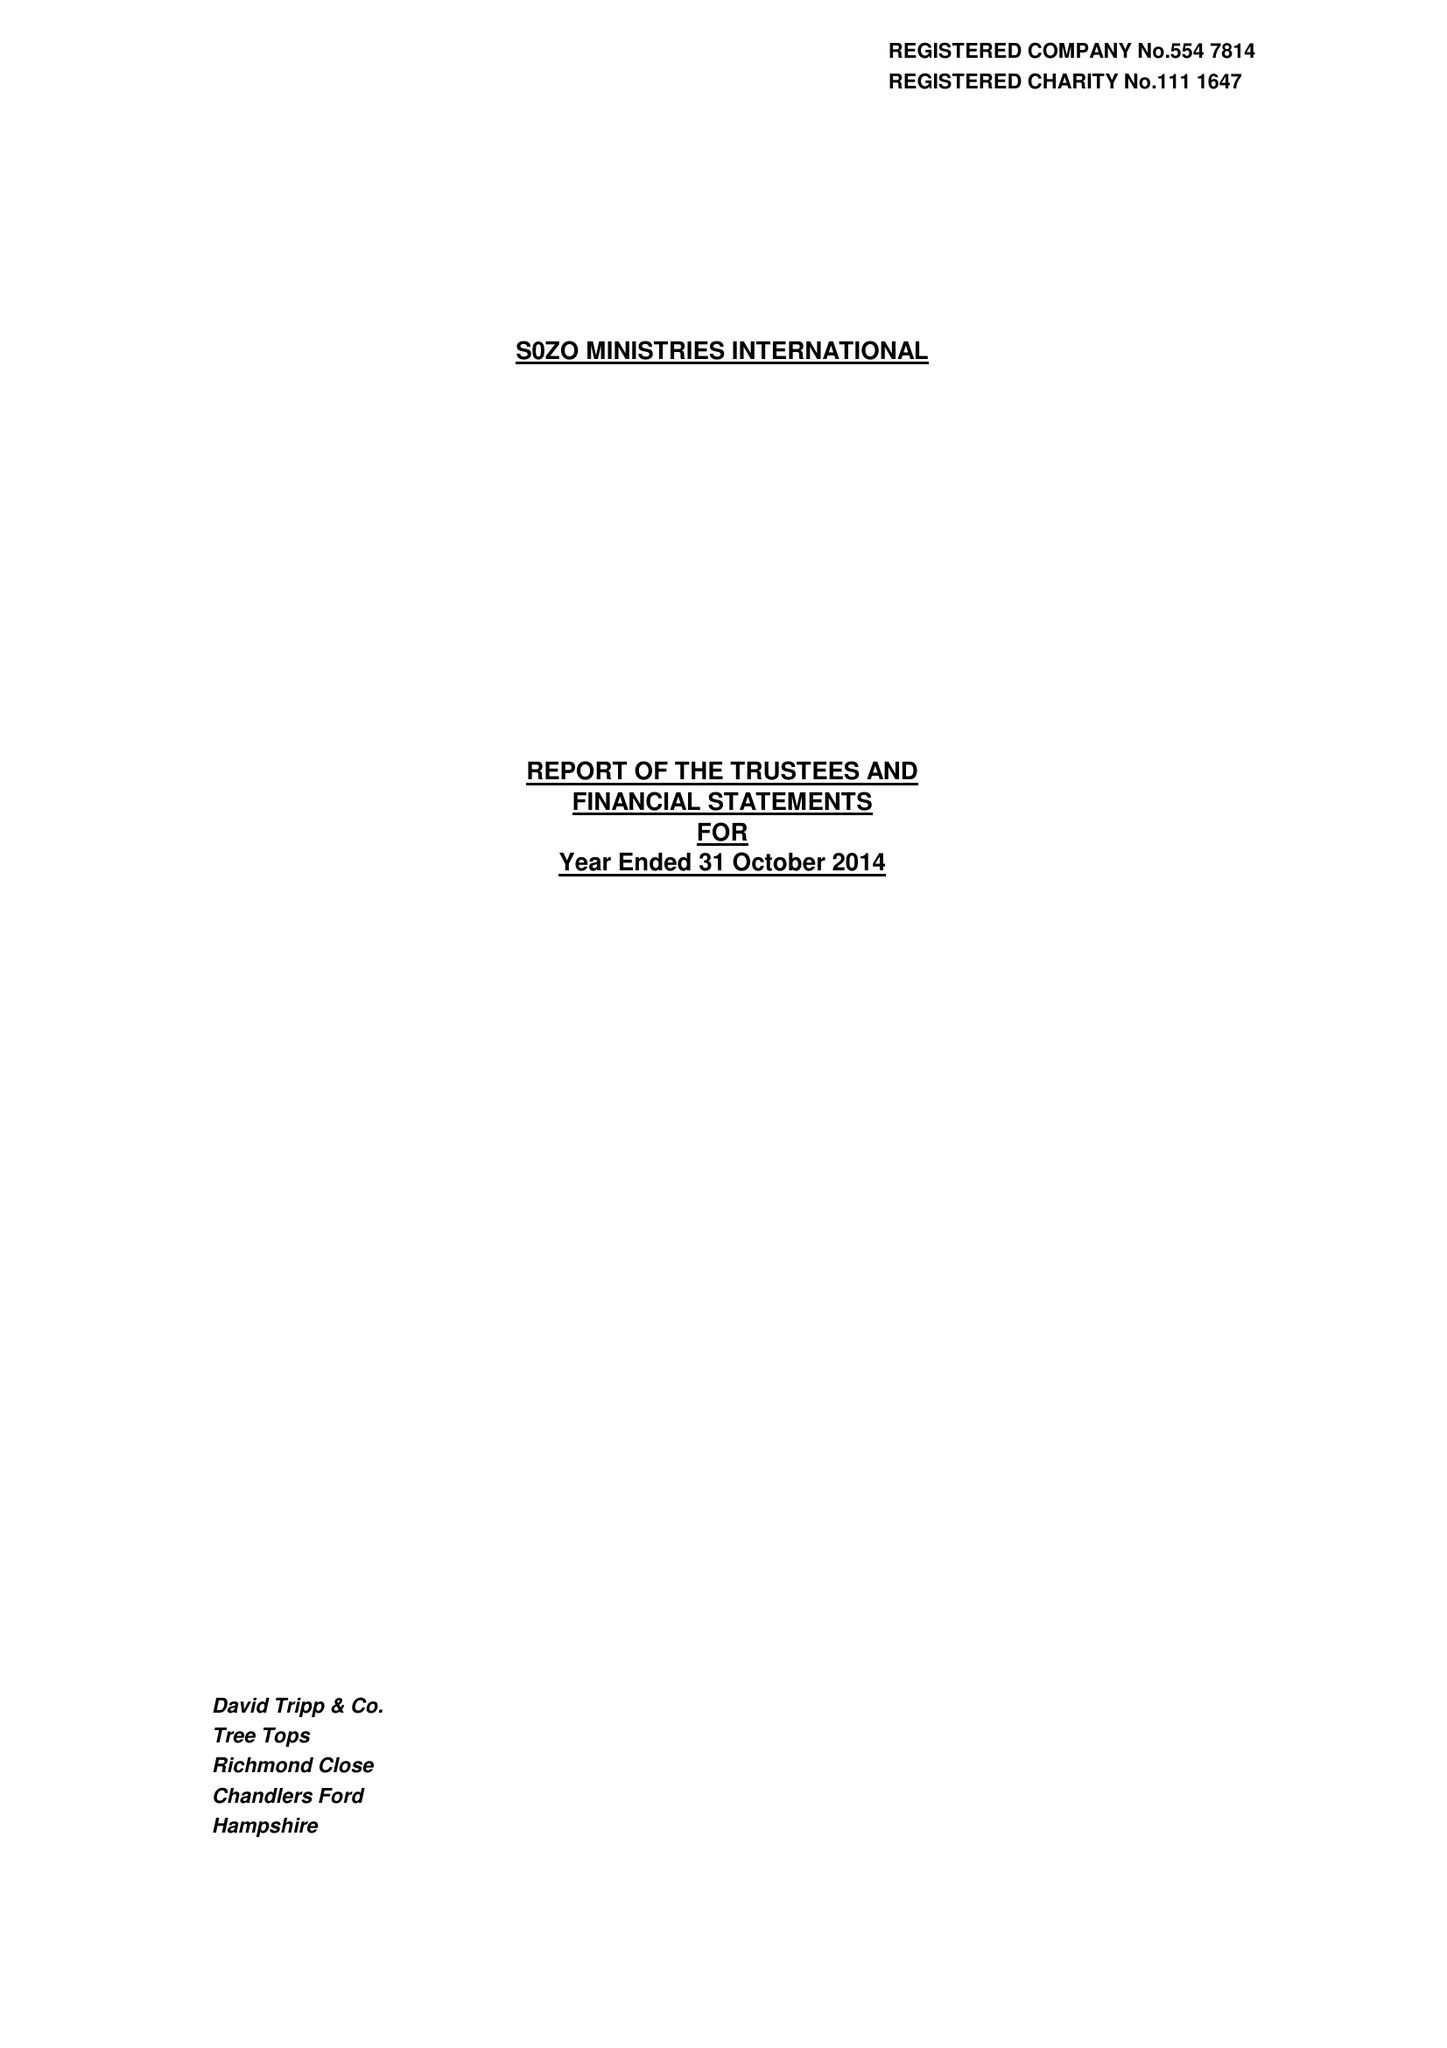What is the value for the charity_name?
Answer the question using a single word or phrase. Sozo Ministries International 